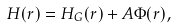<formula> <loc_0><loc_0><loc_500><loc_500>H ( { r } ) = H _ { G } ( { r } ) + A \Phi ( { r } ) ,</formula> 